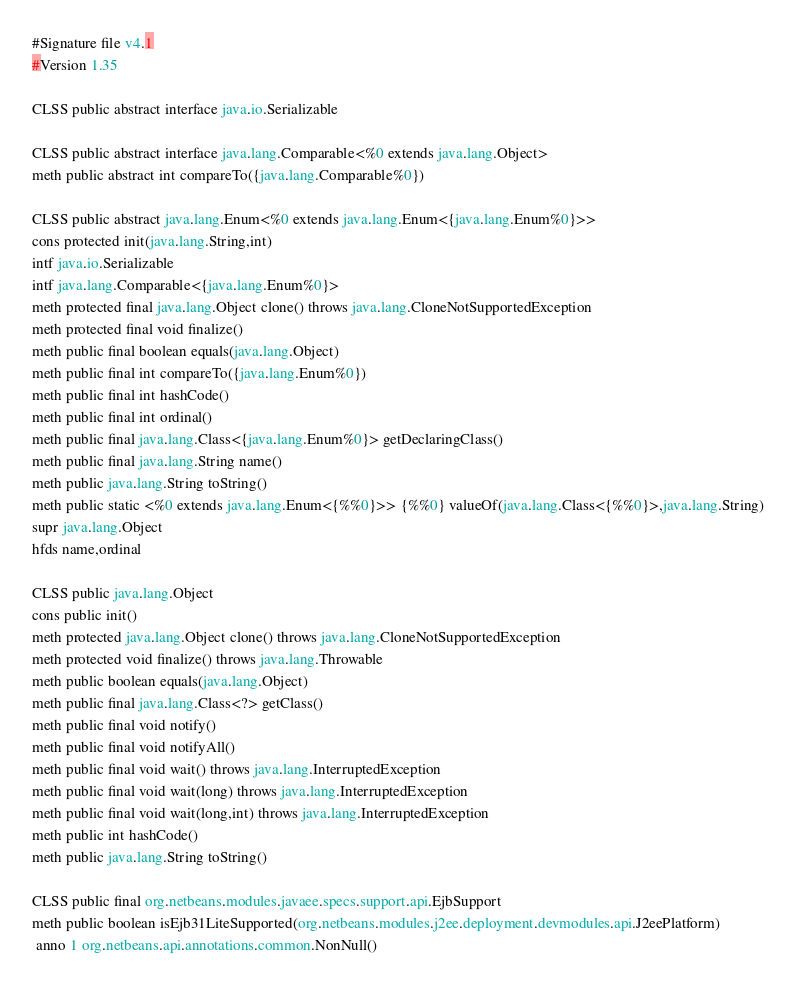Convert code to text. <code><loc_0><loc_0><loc_500><loc_500><_SML_>#Signature file v4.1
#Version 1.35

CLSS public abstract interface java.io.Serializable

CLSS public abstract interface java.lang.Comparable<%0 extends java.lang.Object>
meth public abstract int compareTo({java.lang.Comparable%0})

CLSS public abstract java.lang.Enum<%0 extends java.lang.Enum<{java.lang.Enum%0}>>
cons protected init(java.lang.String,int)
intf java.io.Serializable
intf java.lang.Comparable<{java.lang.Enum%0}>
meth protected final java.lang.Object clone() throws java.lang.CloneNotSupportedException
meth protected final void finalize()
meth public final boolean equals(java.lang.Object)
meth public final int compareTo({java.lang.Enum%0})
meth public final int hashCode()
meth public final int ordinal()
meth public final java.lang.Class<{java.lang.Enum%0}> getDeclaringClass()
meth public final java.lang.String name()
meth public java.lang.String toString()
meth public static <%0 extends java.lang.Enum<{%%0}>> {%%0} valueOf(java.lang.Class<{%%0}>,java.lang.String)
supr java.lang.Object
hfds name,ordinal

CLSS public java.lang.Object
cons public init()
meth protected java.lang.Object clone() throws java.lang.CloneNotSupportedException
meth protected void finalize() throws java.lang.Throwable
meth public boolean equals(java.lang.Object)
meth public final java.lang.Class<?> getClass()
meth public final void notify()
meth public final void notifyAll()
meth public final void wait() throws java.lang.InterruptedException
meth public final void wait(long) throws java.lang.InterruptedException
meth public final void wait(long,int) throws java.lang.InterruptedException
meth public int hashCode()
meth public java.lang.String toString()

CLSS public final org.netbeans.modules.javaee.specs.support.api.EjbSupport
meth public boolean isEjb31LiteSupported(org.netbeans.modules.j2ee.deployment.devmodules.api.J2eePlatform)
 anno 1 org.netbeans.api.annotations.common.NonNull()</code> 